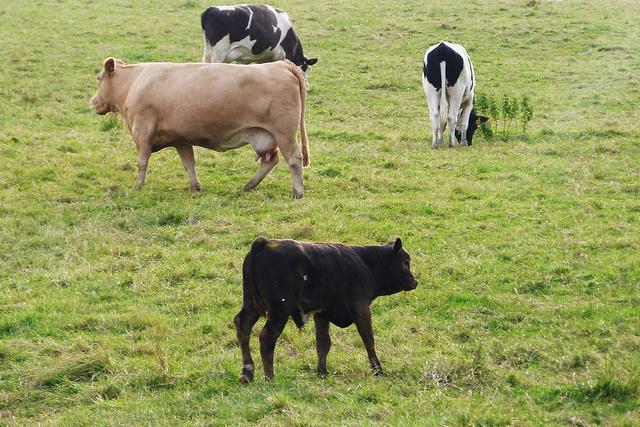How many animals are eating?
Give a very brief answer. 2. How many white cows appear in the photograph?
Give a very brief answer. 2. How many animals are in the picture?
Give a very brief answer. 4. How many cows are there?
Give a very brief answer. 4. 